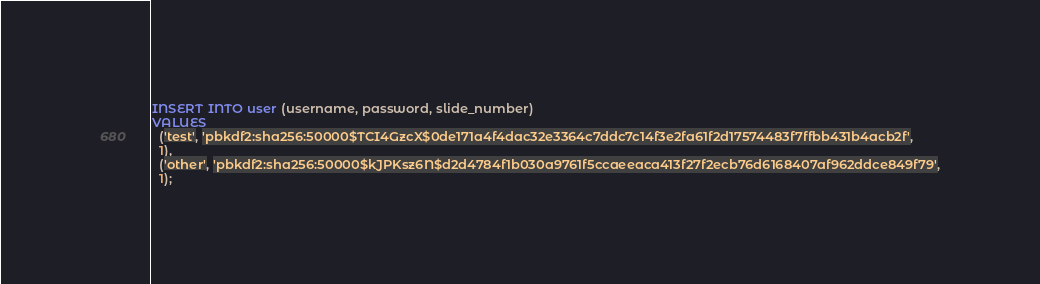<code> <loc_0><loc_0><loc_500><loc_500><_SQL_>INSERT INTO user (username, password, slide_number)
VALUES
  ('test', 'pbkdf2:sha256:50000$TCI4GzcX$0de171a4f4dac32e3364c7ddc7c14f3e2fa61f2d17574483f7ffbb431b4acb2f',
  1),
  ('other', 'pbkdf2:sha256:50000$kJPKsz6N$d2d4784f1b030a9761f5ccaeeaca413f27f2ecb76d6168407af962ddce849f79',
  1);</code> 